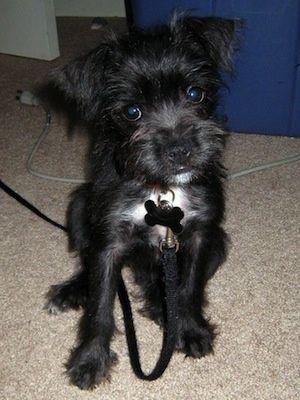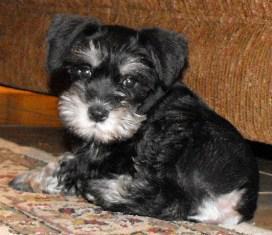The first image is the image on the left, the second image is the image on the right. For the images shown, is this caption "Two black puppies are side-by-side and turned forward in the right image." true? Answer yes or no. No. The first image is the image on the left, the second image is the image on the right. Assess this claim about the two images: "There are three dogs waiting at attention.". Correct or not? Answer yes or no. No. 